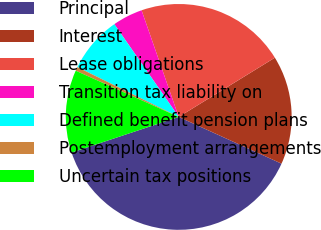<chart> <loc_0><loc_0><loc_500><loc_500><pie_chart><fcel>Principal<fcel>Interest<fcel>Lease obligations<fcel>Transition tax liability on<fcel>Defined benefit pension plans<fcel>Postemployment arrangements<fcel>Uncertain tax positions<nl><fcel>38.1%<fcel>15.58%<fcel>21.55%<fcel>4.32%<fcel>8.07%<fcel>0.56%<fcel>11.82%<nl></chart> 